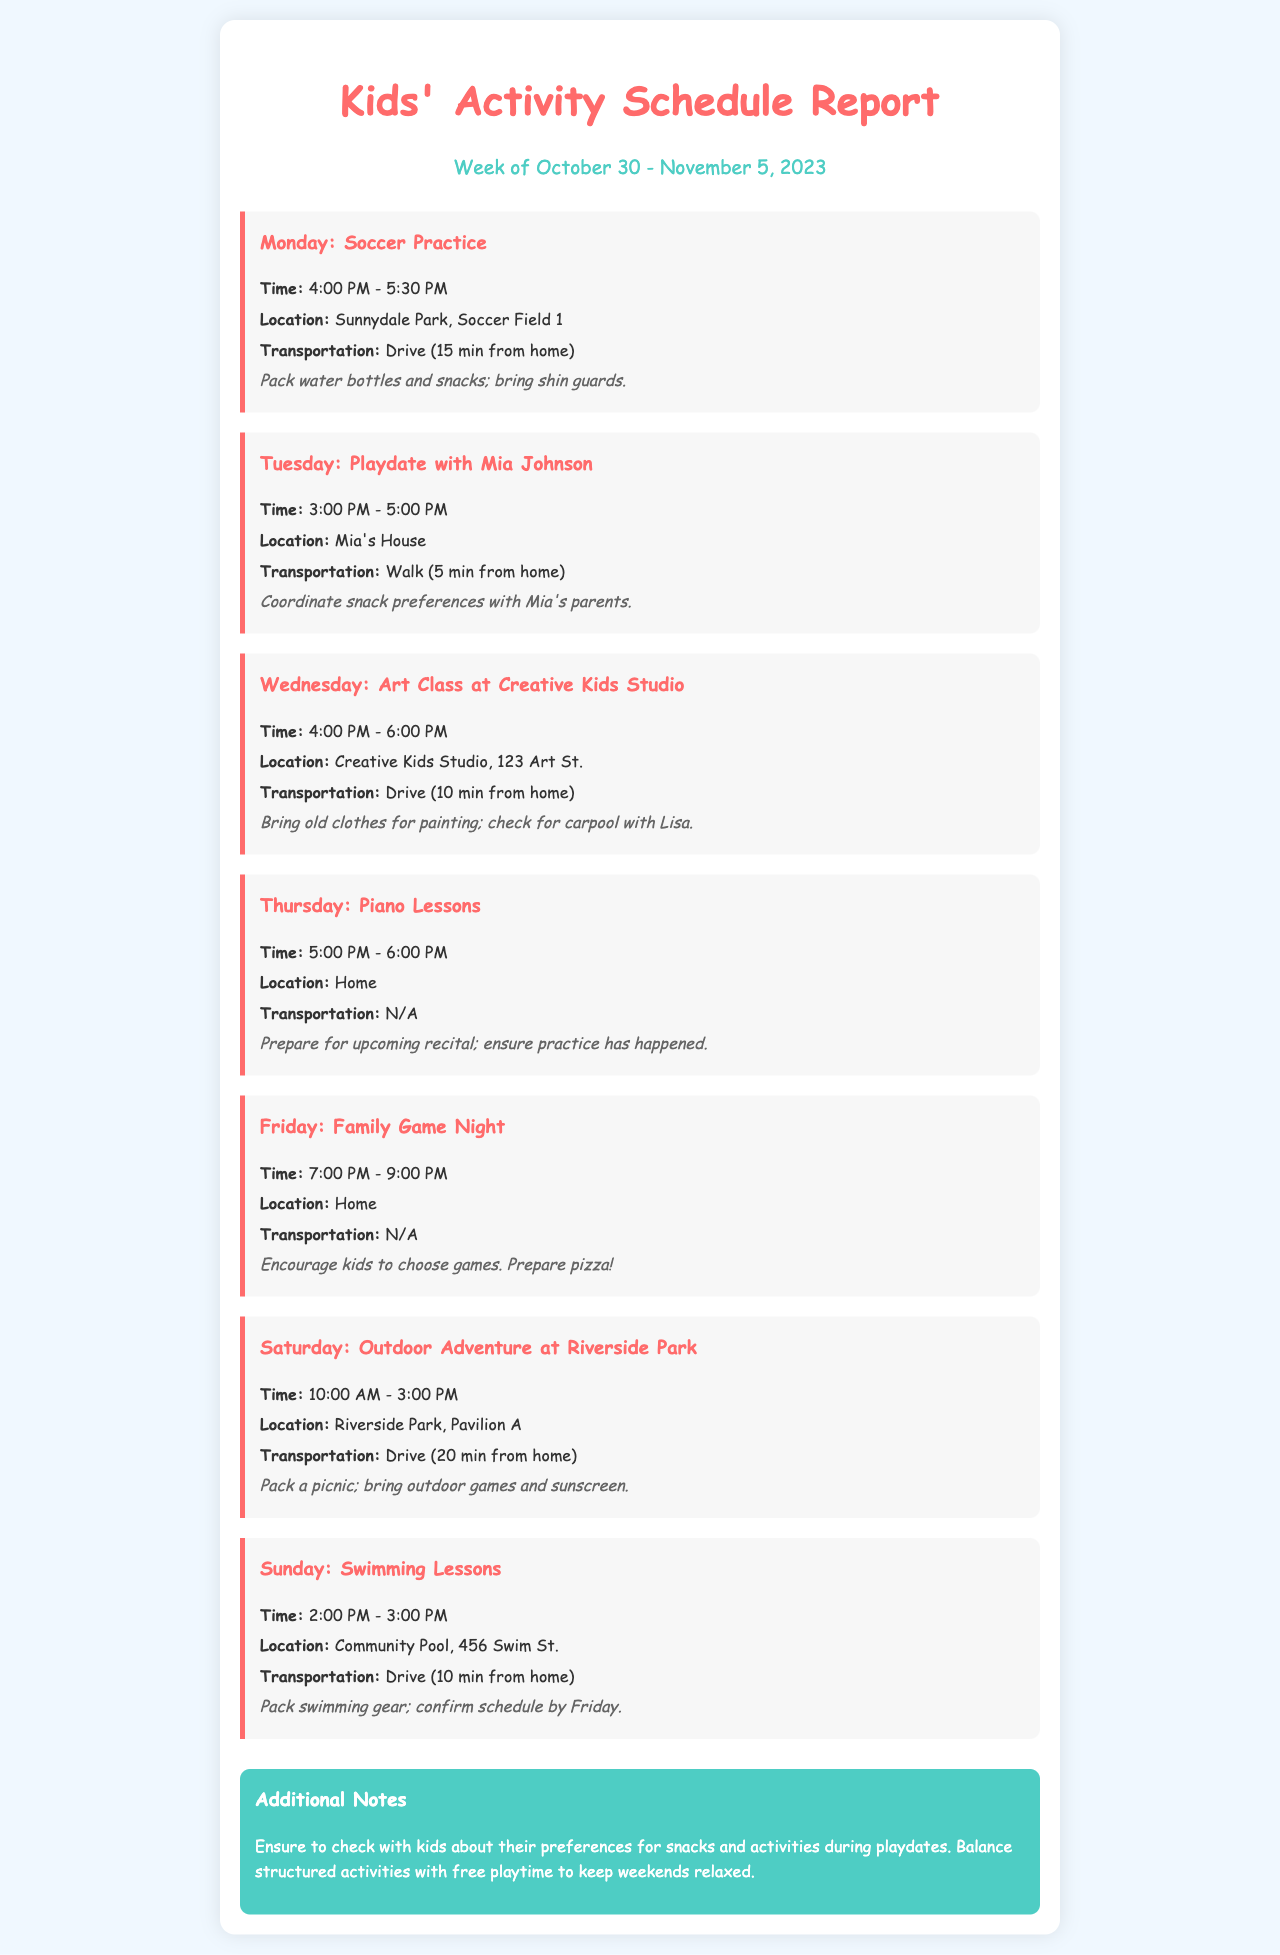What activity is scheduled for Monday? The document lists soccer practice as the activity scheduled for Monday.
Answer: Soccer Practice What time does the swimming lessons start on Sunday? The document specifies that swimming lessons start at 2:00 PM on Sunday.
Answer: 2:00 PM How long is the outdoor adventure scheduled for? The document indicates that the outdoor adventure lasts from 10:00 AM to 3:00 PM, which is a duration of 5 hours.
Answer: 5 hours What is the transportation method for the soccer practice? The document states that the transportation method for soccer practice is driving, which takes 15 minutes from home.
Answer: Drive (15 min) What preparations are suggested for the Friday Family Game Night? The document notes that preparations include encouraging kids to choose games and preparing pizza.
Answer: Prepare pizza How many activities are scheduled for Saturday? The document lists only one activity scheduled for Saturday, which is the outdoor adventure.
Answer: 1 activity What is the location for Wednesday's art class? The document indicates that the location for Wednesday's art class is Creative Kids Studio, 123 Art St.
Answer: Creative Kids Studio, 123 Art St What additional item is recommended to pack for the Saturday outdoor adventure? The document suggests packing a picnic and outdoor games for the Saturday outdoor adventure.
Answer: Picnic and outdoor games 